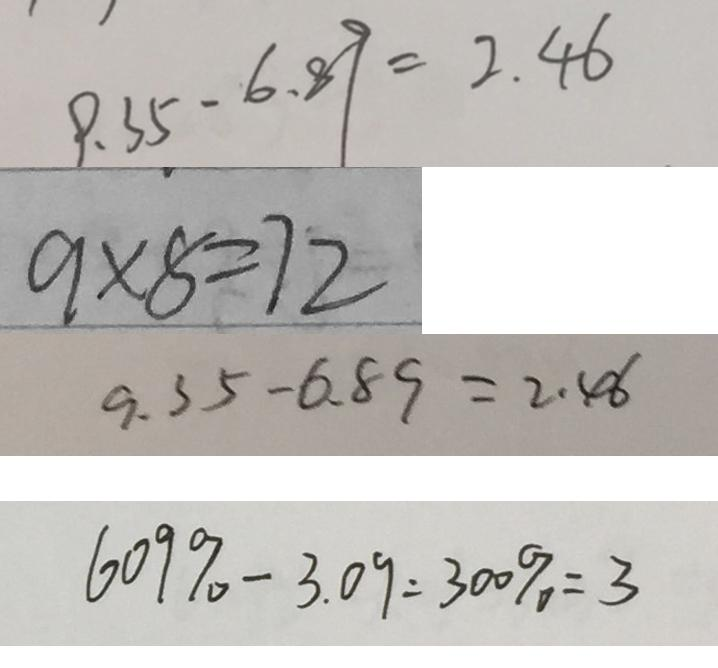<formula> <loc_0><loc_0><loc_500><loc_500>9 . 3 5 - 6 . 8 9 = 2 . 4 6 
 9 \times 8 = 7 2 
 9 . 3 5 - 6 . 8 9 = 2 . 4 6 
 6 0 9 \% - 3 . 0 9 = 3 0 0 \% = 3</formula> 